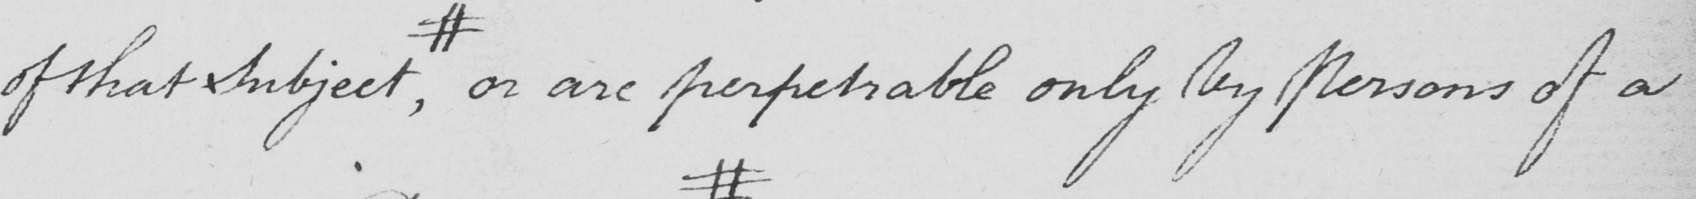Please provide the text content of this handwritten line. of that Subject  , # or are perpetrable only By Persons of a 